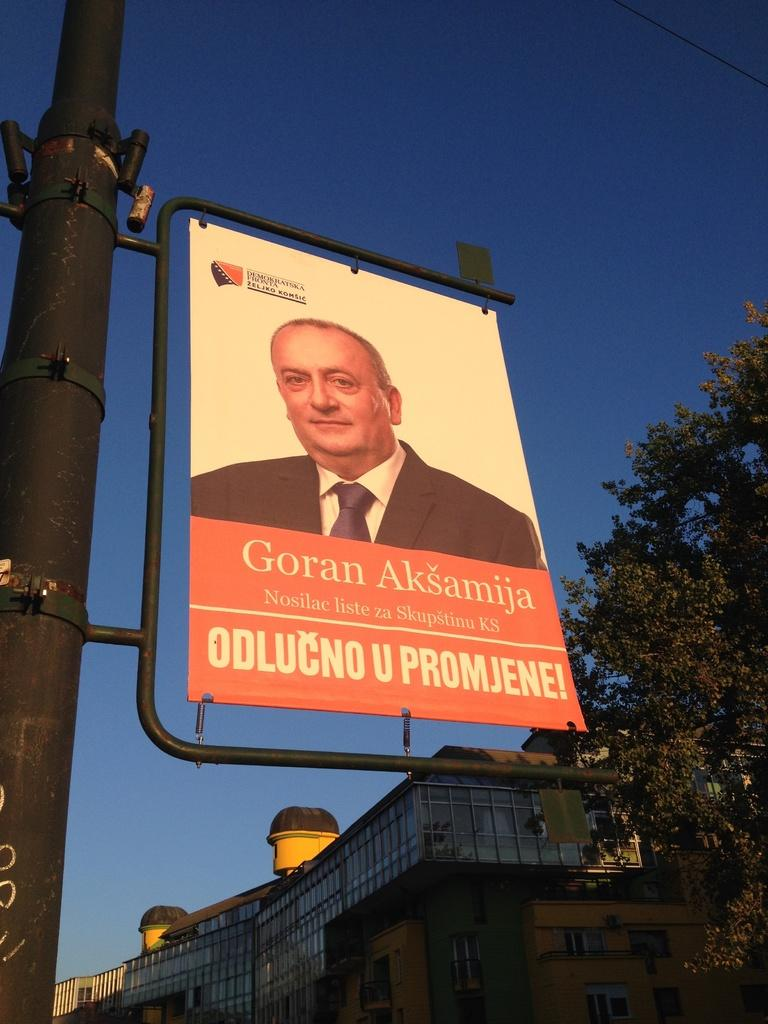Provide a one-sentence caption for the provided image. A sign featuring Goran Aksamija hangs on a post. 